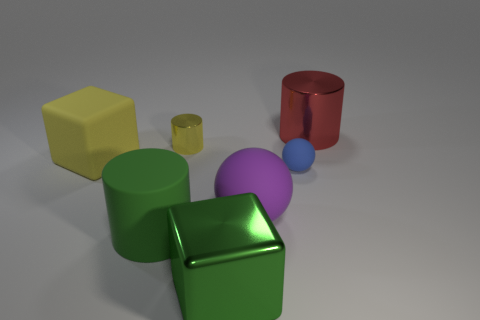Add 3 big purple objects. How many objects exist? 10 Subtract all cylinders. How many objects are left? 4 Add 4 large purple objects. How many large purple objects are left? 5 Add 2 cyan rubber cubes. How many cyan rubber cubes exist? 2 Subtract 0 brown cylinders. How many objects are left? 7 Subtract all small metal cubes. Subtract all big matte spheres. How many objects are left? 6 